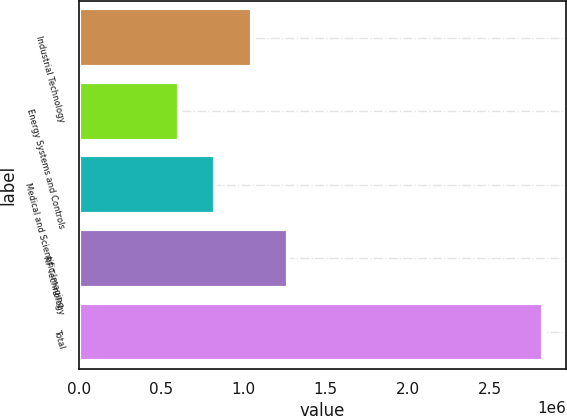Convert chart. <chart><loc_0><loc_0><loc_500><loc_500><bar_chart><fcel>Industrial Technology<fcel>Energy Systems and Controls<fcel>Medical and Scientific Imaging<fcel>RF Technology<fcel>Total<nl><fcel>1.05148e+06<fcel>608538<fcel>830009<fcel>1.27295e+06<fcel>2.82325e+06<nl></chart> 